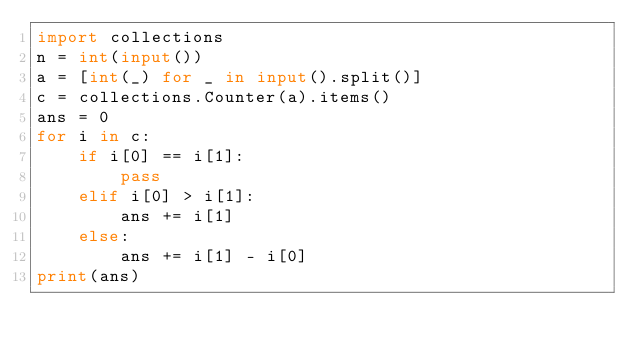<code> <loc_0><loc_0><loc_500><loc_500><_Python_>import collections
n = int(input())
a = [int(_) for _ in input().split()]
c = collections.Counter(a).items()
ans = 0
for i in c:
    if i[0] == i[1]:
        pass
    elif i[0] > i[1]:
        ans += i[1]
    else:
        ans += i[1] - i[0]
print(ans)</code> 